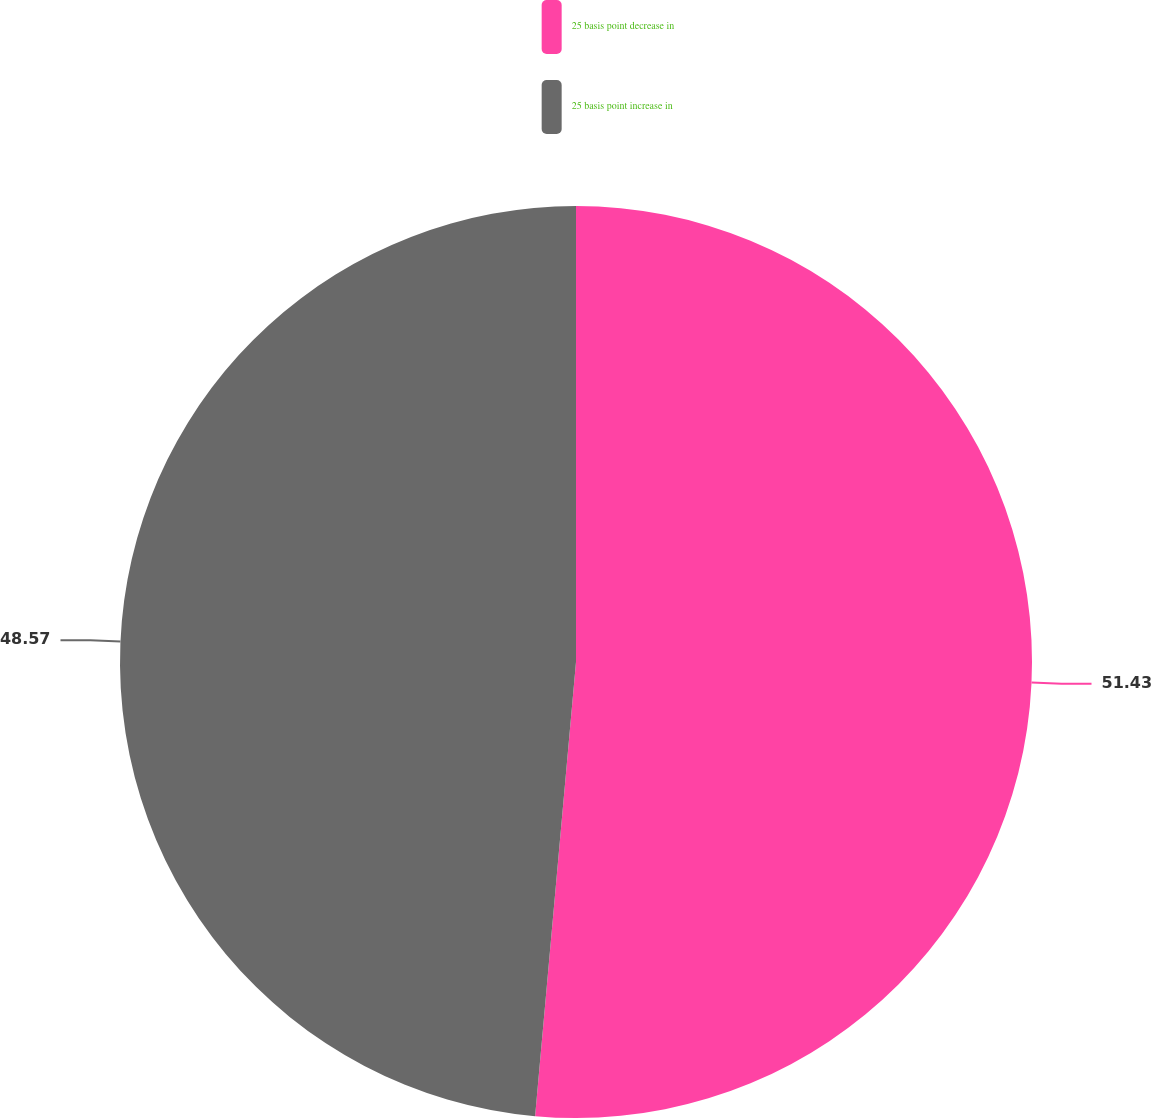Convert chart. <chart><loc_0><loc_0><loc_500><loc_500><pie_chart><fcel>25 basis point decrease in<fcel>25 basis point increase in<nl><fcel>51.43%<fcel>48.57%<nl></chart> 